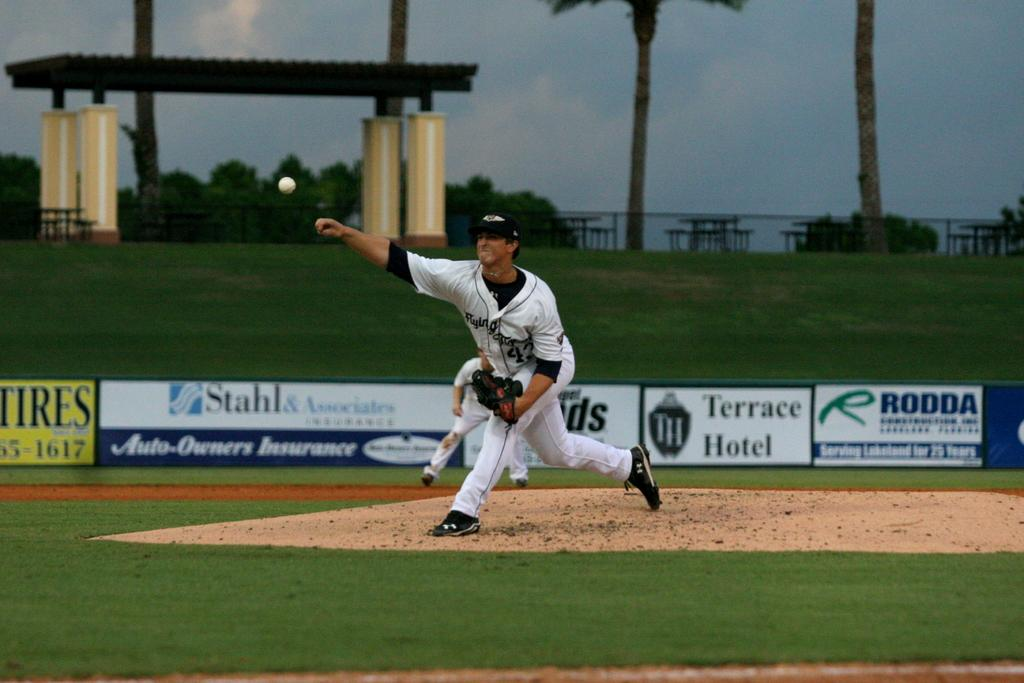Provide a one-sentence caption for the provided image. A baseball player has thrown a ball with ads in the background for RODDA, Terrace Hotel, Stahl & Associates Auto-Owners Insurance. 